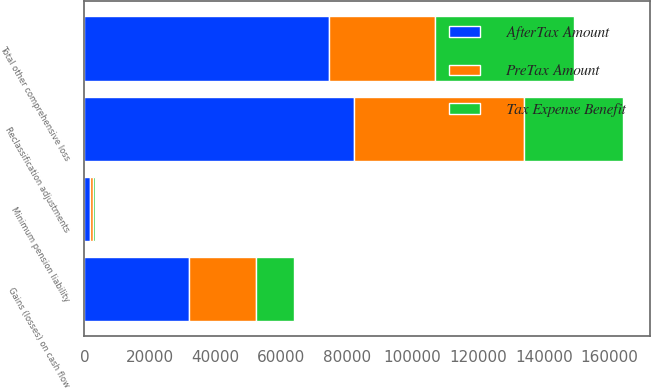Convert chart. <chart><loc_0><loc_0><loc_500><loc_500><stacked_bar_chart><ecel><fcel>Minimum pension liability<fcel>Gains (losses) on cash flow<fcel>Reclassification adjustments<fcel>Total other comprehensive loss<nl><fcel>AfterTax Amount<fcel>1565<fcel>31971<fcel>82012<fcel>74610<nl><fcel>Tax Expense Benefit<fcel>623<fcel>11732<fcel>30099<fcel>42454<nl><fcel>PreTax Amount<fcel>942<fcel>20239<fcel>51913<fcel>32156<nl></chart> 